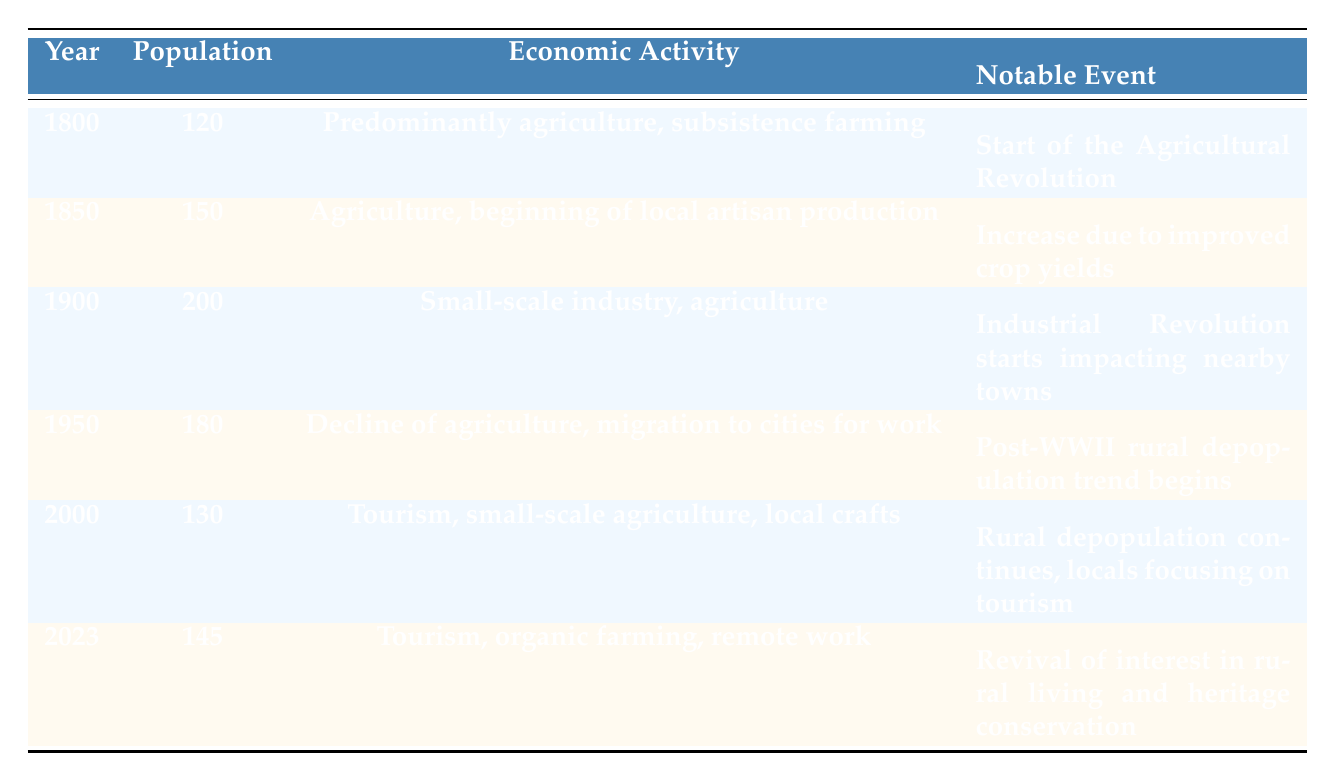What was the population in 1900? The table shows that in the year 1900, the population of the village was listed as 200.
Answer: 200 What notable event occurred in 1950? According to the table, the notable event in 1950 was the beginning of the post-WWII rural depopulation trend.
Answer: Post-WWII rural depopulation trend begins How many people lived in the village in 1800 compared to 2023? In 1800, the population was 120, while in 2023 it was 145. Therefore, the village had 25 more inhabitants in 2023 than in 1800.
Answer: 25 Did the population increase from 1850 to 1900? Yes, the population increased from 150 in 1850 to 200 in 1900, indicating a growth trend during that period.
Answer: Yes What is the overall trend in the village's population from 1950 to 2000? In 1950, the population was 180, and by 2000, it had decreased to 130. This indicates a declining trend over that period.
Answer: Declining trend What was the average population of the village across the recorded years? To find the average population, sum the populations (120 + 150 + 200 + 180 + 130 + 145 = 1025) and divide by the number of years (6). This gives an average of 1025 / 6, which is approximately 170.83.
Answer: Approximately 170.83 Is agriculture mentioned as a predominant economic activity after 1950? No, after 1950, the economic activity shifted from agriculture to include migration, tourism, and crafts, indicating a decline in agriculture's predominance.
Answer: No What was the population in 2000, and what notable event accompanied it? In 2000, the population was 130, and the notable event recorded was the continuation of rural depopulation with a focus on tourism.
Answer: 130, Rural depopulation continues and focuses on tourism Which year marked the highest population recorded in the table? The year 1900 marked the highest population recorded in the table with 200 inhabitants.
Answer: 1900 